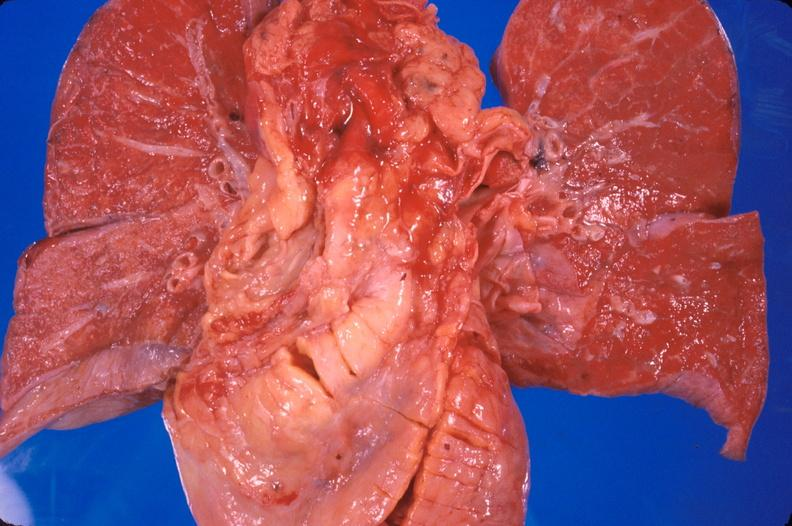s cardiovascular present?
Answer the question using a single word or phrase. Yes 